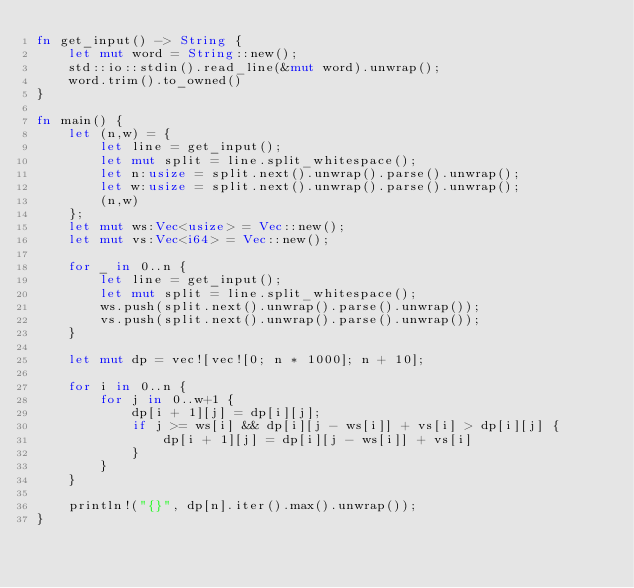Convert code to text. <code><loc_0><loc_0><loc_500><loc_500><_Rust_>fn get_input() -> String {
    let mut word = String::new();
    std::io::stdin().read_line(&mut word).unwrap();
    word.trim().to_owned()
}

fn main() {
    let (n,w) = {
        let line = get_input();
        let mut split = line.split_whitespace();
        let n:usize = split.next().unwrap().parse().unwrap();
        let w:usize = split.next().unwrap().parse().unwrap();
        (n,w)
    };
    let mut ws:Vec<usize> = Vec::new();
    let mut vs:Vec<i64> = Vec::new();

    for _ in 0..n {
        let line = get_input();
        let mut split = line.split_whitespace();
        ws.push(split.next().unwrap().parse().unwrap());
        vs.push(split.next().unwrap().parse().unwrap());
    }

    let mut dp = vec![vec![0; n * 1000]; n + 10];

    for i in 0..n {
        for j in 0..w+1 {
            dp[i + 1][j] = dp[i][j];
            if j >= ws[i] && dp[i][j - ws[i]] + vs[i] > dp[i][j] {
                dp[i + 1][j] = dp[i][j - ws[i]] + vs[i]
            }
        }
    }

    println!("{}", dp[n].iter().max().unwrap());
}
</code> 